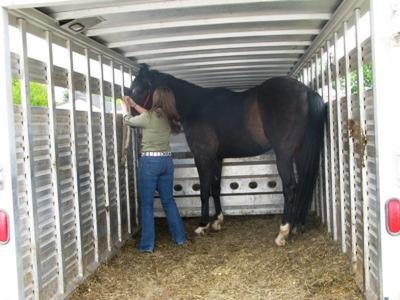Are they in a barn?
Answer briefly. No. What color is the horse?
Short answer required. Black. What is next to the female?
Give a very brief answer. Horse. 